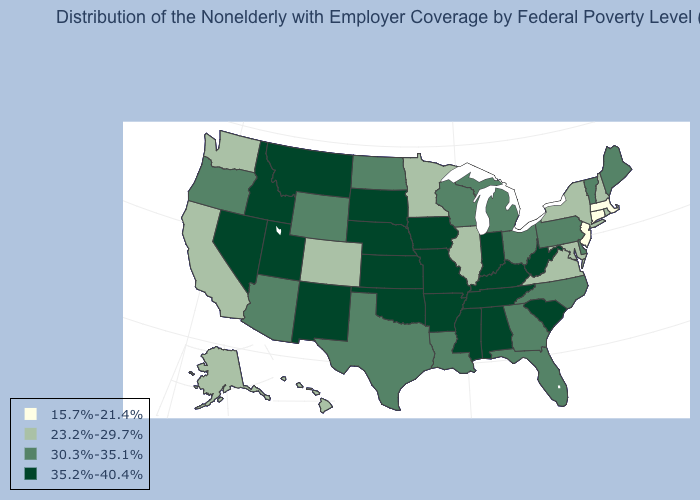What is the value of New Jersey?
Short answer required. 15.7%-21.4%. Which states have the lowest value in the USA?
Write a very short answer. Connecticut, Massachusetts, New Jersey. What is the value of Oregon?
Concise answer only. 30.3%-35.1%. Which states have the lowest value in the USA?
Concise answer only. Connecticut, Massachusetts, New Jersey. Does Kentucky have the same value as Rhode Island?
Be succinct. No. Which states have the lowest value in the USA?
Write a very short answer. Connecticut, Massachusetts, New Jersey. Among the states that border New Jersey , does Delaware have the highest value?
Be succinct. Yes. What is the highest value in the Northeast ?
Concise answer only. 30.3%-35.1%. Name the states that have a value in the range 35.2%-40.4%?
Keep it brief. Alabama, Arkansas, Idaho, Indiana, Iowa, Kansas, Kentucky, Mississippi, Missouri, Montana, Nebraska, Nevada, New Mexico, Oklahoma, South Carolina, South Dakota, Tennessee, Utah, West Virginia. Among the states that border Tennessee , does Virginia have the lowest value?
Answer briefly. Yes. Does Wyoming have the same value as Washington?
Keep it brief. No. Does Arizona have the lowest value in the USA?
Quick response, please. No. Name the states that have a value in the range 30.3%-35.1%?
Be succinct. Arizona, Delaware, Florida, Georgia, Louisiana, Maine, Michigan, North Carolina, North Dakota, Ohio, Oregon, Pennsylvania, Texas, Vermont, Wisconsin, Wyoming. Name the states that have a value in the range 23.2%-29.7%?
Quick response, please. Alaska, California, Colorado, Hawaii, Illinois, Maryland, Minnesota, New Hampshire, New York, Rhode Island, Virginia, Washington. Which states hav the highest value in the South?
Give a very brief answer. Alabama, Arkansas, Kentucky, Mississippi, Oklahoma, South Carolina, Tennessee, West Virginia. 